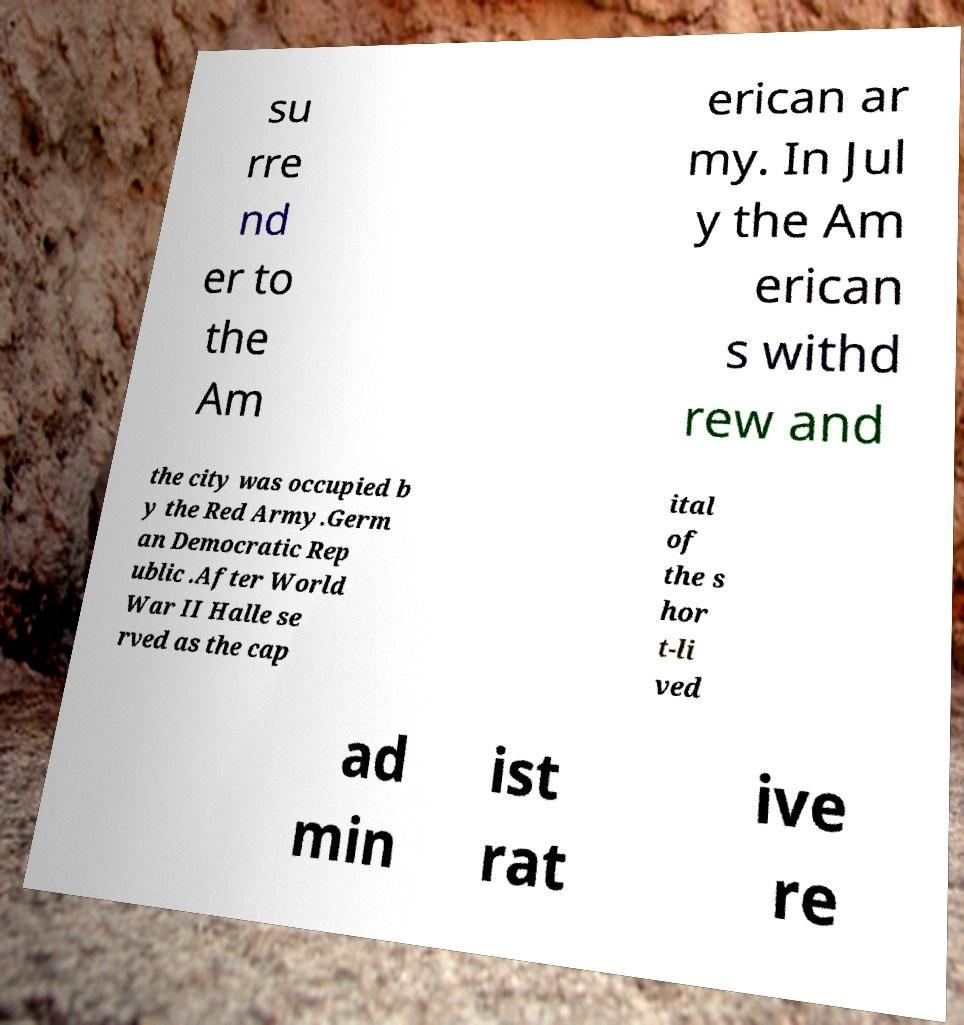What messages or text are displayed in this image? I need them in a readable, typed format. su rre nd er to the Am erican ar my. In Jul y the Am erican s withd rew and the city was occupied b y the Red Army.Germ an Democratic Rep ublic .After World War II Halle se rved as the cap ital of the s hor t-li ved ad min ist rat ive re 